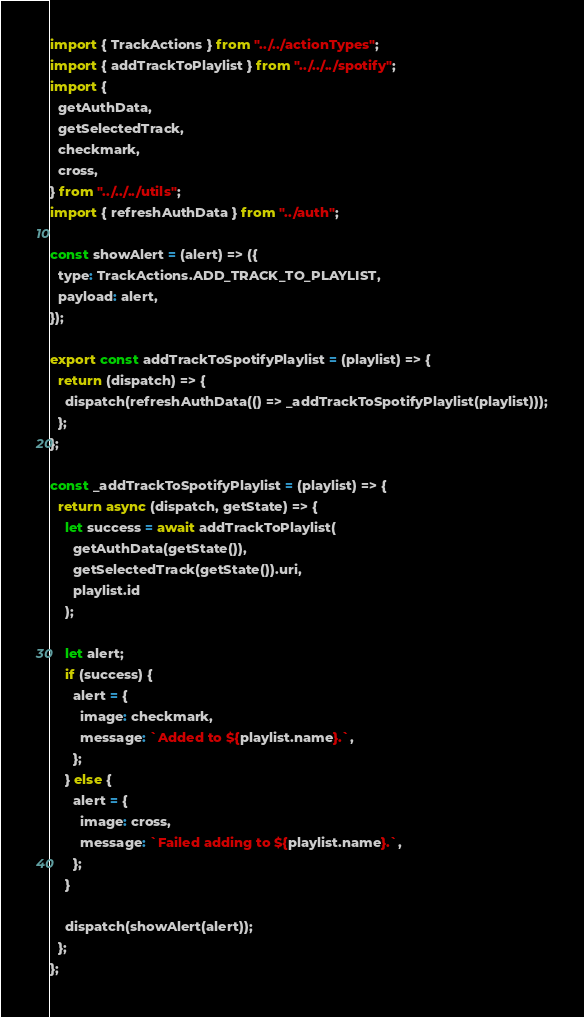<code> <loc_0><loc_0><loc_500><loc_500><_JavaScript_>import { TrackActions } from "../../actionTypes";
import { addTrackToPlaylist } from "../../../spotify";
import {
  getAuthData,
  getSelectedTrack,
  checkmark,
  cross,
} from "../../../utils";
import { refreshAuthData } from "../auth";

const showAlert = (alert) => ({
  type: TrackActions.ADD_TRACK_TO_PLAYLIST,
  payload: alert,
});

export const addTrackToSpotifyPlaylist = (playlist) => {
  return (dispatch) => {
    dispatch(refreshAuthData(() => _addTrackToSpotifyPlaylist(playlist)));
  };
};

const _addTrackToSpotifyPlaylist = (playlist) => {
  return async (dispatch, getState) => {
    let success = await addTrackToPlaylist(
      getAuthData(getState()),
      getSelectedTrack(getState()).uri,
      playlist.id
    );

    let alert;
    if (success) {
      alert = {
        image: checkmark,
        message: `Added to ${playlist.name}.`,
      };
    } else {
      alert = {
        image: cross,
        message: `Failed adding to ${playlist.name}.`,
      };
    }

    dispatch(showAlert(alert));
  };
};
</code> 